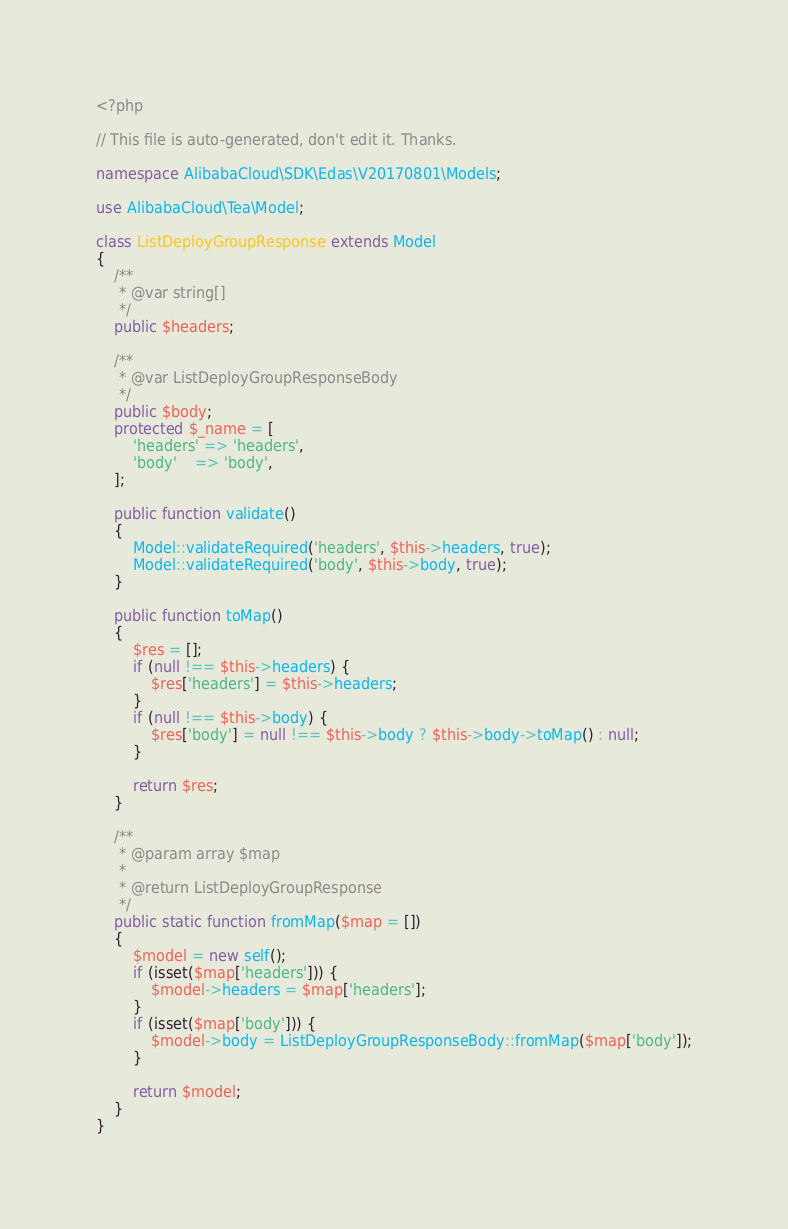<code> <loc_0><loc_0><loc_500><loc_500><_PHP_><?php

// This file is auto-generated, don't edit it. Thanks.

namespace AlibabaCloud\SDK\Edas\V20170801\Models;

use AlibabaCloud\Tea\Model;

class ListDeployGroupResponse extends Model
{
    /**
     * @var string[]
     */
    public $headers;

    /**
     * @var ListDeployGroupResponseBody
     */
    public $body;
    protected $_name = [
        'headers' => 'headers',
        'body'    => 'body',
    ];

    public function validate()
    {
        Model::validateRequired('headers', $this->headers, true);
        Model::validateRequired('body', $this->body, true);
    }

    public function toMap()
    {
        $res = [];
        if (null !== $this->headers) {
            $res['headers'] = $this->headers;
        }
        if (null !== $this->body) {
            $res['body'] = null !== $this->body ? $this->body->toMap() : null;
        }

        return $res;
    }

    /**
     * @param array $map
     *
     * @return ListDeployGroupResponse
     */
    public static function fromMap($map = [])
    {
        $model = new self();
        if (isset($map['headers'])) {
            $model->headers = $map['headers'];
        }
        if (isset($map['body'])) {
            $model->body = ListDeployGroupResponseBody::fromMap($map['body']);
        }

        return $model;
    }
}
</code> 